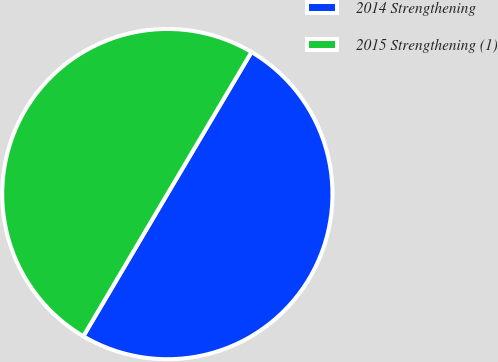Convert chart to OTSL. <chart><loc_0><loc_0><loc_500><loc_500><pie_chart><fcel>2014 Strengthening<fcel>2015 Strengthening (1)<nl><fcel>49.98%<fcel>50.02%<nl></chart> 